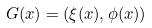<formula> <loc_0><loc_0><loc_500><loc_500>G ( x ) = ( \xi ( x ) , \phi ( x ) )</formula> 